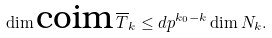<formula> <loc_0><loc_0><loc_500><loc_500>\dim \text {coim} \, \overline { T } _ { k } \leq d p ^ { k _ { 0 } - k } \dim N _ { k } .</formula> 